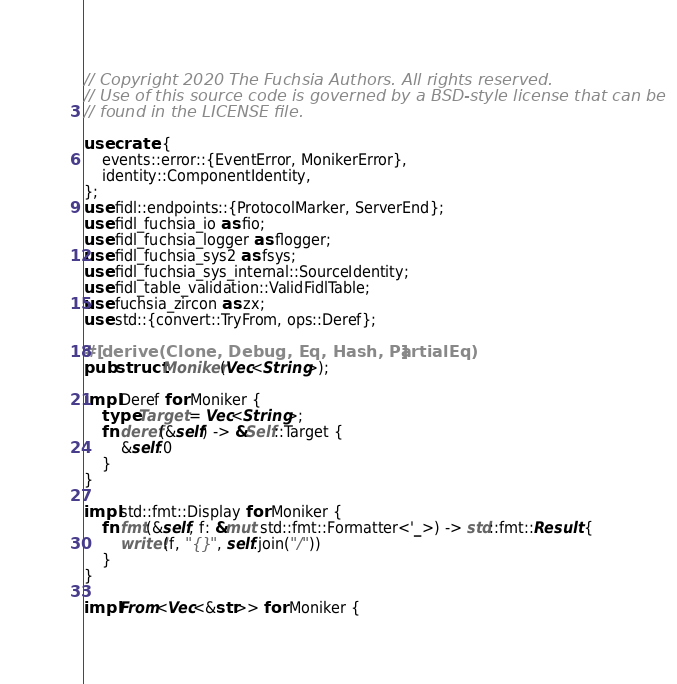<code> <loc_0><loc_0><loc_500><loc_500><_Rust_>// Copyright 2020 The Fuchsia Authors. All rights reserved.
// Use of this source code is governed by a BSD-style license that can be
// found in the LICENSE file.

use crate::{
    events::error::{EventError, MonikerError},
    identity::ComponentIdentity,
};
use fidl::endpoints::{ProtocolMarker, ServerEnd};
use fidl_fuchsia_io as fio;
use fidl_fuchsia_logger as flogger;
use fidl_fuchsia_sys2 as fsys;
use fidl_fuchsia_sys_internal::SourceIdentity;
use fidl_table_validation::ValidFidlTable;
use fuchsia_zircon as zx;
use std::{convert::TryFrom, ops::Deref};

#[derive(Clone, Debug, Eq, Hash, PartialEq)]
pub struct Moniker(Vec<String>);

impl Deref for Moniker {
    type Target = Vec<String>;
    fn deref(&self) -> &Self::Target {
        &self.0
    }
}

impl std::fmt::Display for Moniker {
    fn fmt(&self, f: &mut std::fmt::Formatter<'_>) -> std::fmt::Result {
        write!(f, "{}", self.join("/"))
    }
}

impl From<Vec<&str>> for Moniker {</code> 